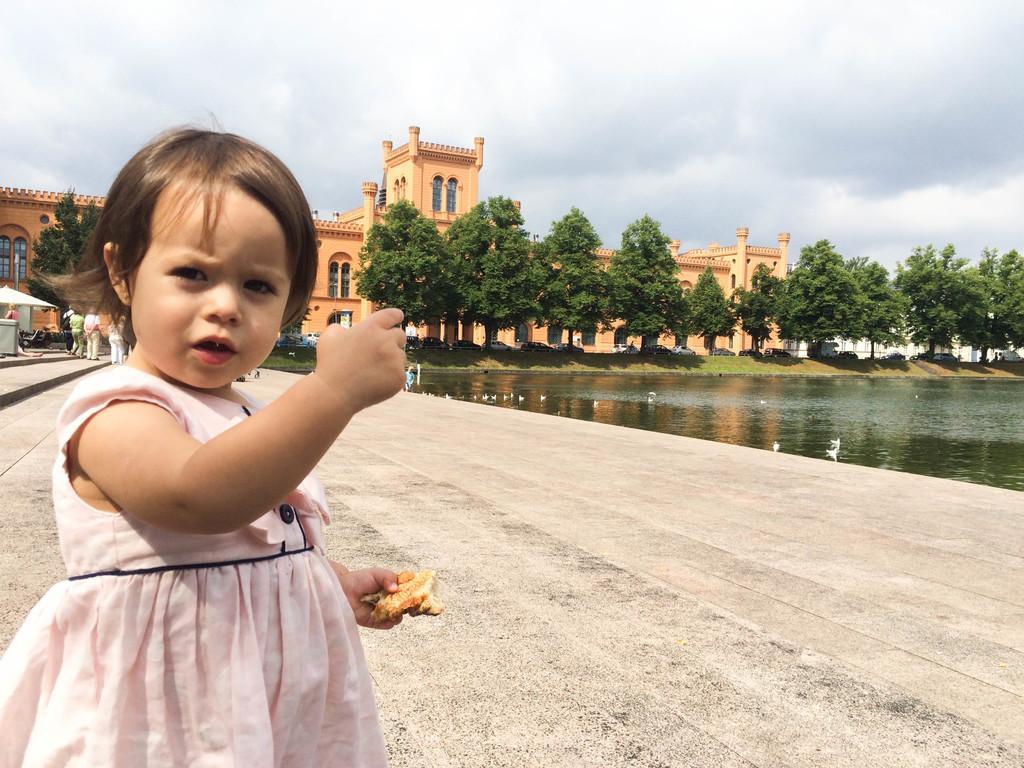Could you give a brief overview of what you see in this image? In the foreground of the image we can see a girl holding food in her hand. To the right side of the image we can see water, group of vehicles parked on the ground, a group of trees. In the center of the image we can see a building with windows. On the left side of the image we can see a group of people standing on the ground and a shed. In the background, we can see the cloudy sky. 